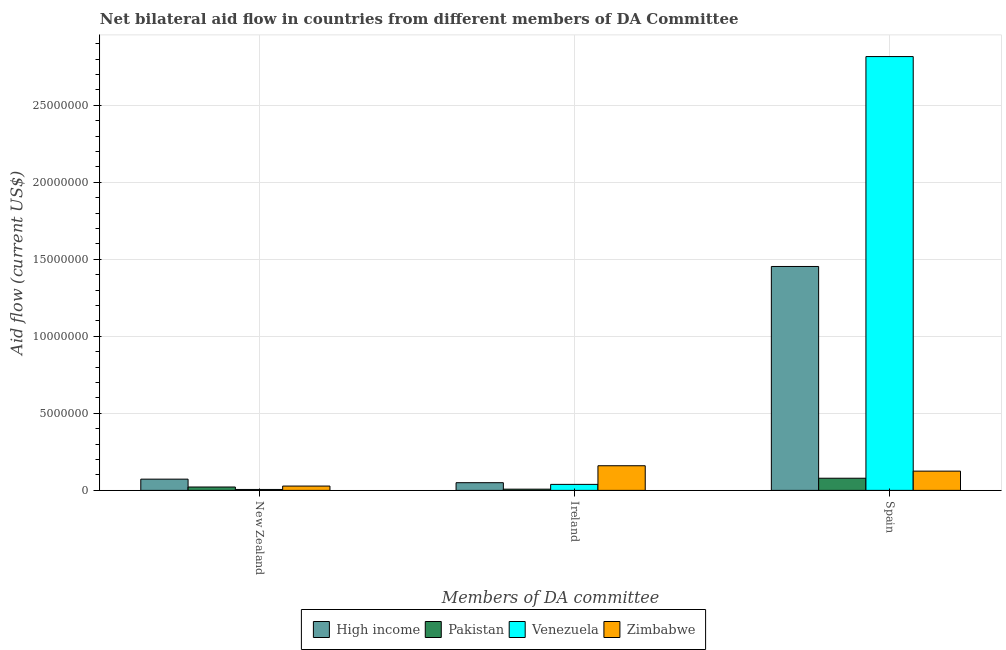How many groups of bars are there?
Provide a succinct answer. 3. Are the number of bars on each tick of the X-axis equal?
Give a very brief answer. Yes. How many bars are there on the 2nd tick from the right?
Keep it short and to the point. 4. What is the label of the 3rd group of bars from the left?
Keep it short and to the point. Spain. What is the amount of aid provided by ireland in Venezuela?
Offer a very short reply. 3.90e+05. Across all countries, what is the maximum amount of aid provided by new zealand?
Offer a very short reply. 7.30e+05. Across all countries, what is the minimum amount of aid provided by ireland?
Offer a terse response. 8.00e+04. In which country was the amount of aid provided by spain maximum?
Offer a very short reply. Venezuela. In which country was the amount of aid provided by spain minimum?
Keep it short and to the point. Pakistan. What is the total amount of aid provided by ireland in the graph?
Offer a terse response. 2.57e+06. What is the difference between the amount of aid provided by spain in High income and that in Zimbabwe?
Make the answer very short. 1.33e+07. What is the difference between the amount of aid provided by ireland in High income and the amount of aid provided by new zealand in Zimbabwe?
Offer a terse response. 2.20e+05. What is the average amount of aid provided by spain per country?
Your answer should be compact. 1.12e+07. What is the difference between the amount of aid provided by ireland and amount of aid provided by spain in High income?
Make the answer very short. -1.40e+07. In how many countries, is the amount of aid provided by ireland greater than 4000000 US$?
Ensure brevity in your answer.  0. What is the ratio of the amount of aid provided by ireland in High income to that in Zimbabwe?
Provide a succinct answer. 0.31. Is the amount of aid provided by new zealand in Pakistan less than that in Zimbabwe?
Give a very brief answer. Yes. Is the difference between the amount of aid provided by new zealand in Venezuela and Zimbabwe greater than the difference between the amount of aid provided by ireland in Venezuela and Zimbabwe?
Offer a terse response. Yes. What is the difference between the highest and the second highest amount of aid provided by ireland?
Provide a succinct answer. 1.10e+06. What is the difference between the highest and the lowest amount of aid provided by ireland?
Ensure brevity in your answer.  1.52e+06. In how many countries, is the amount of aid provided by spain greater than the average amount of aid provided by spain taken over all countries?
Keep it short and to the point. 2. What does the 3rd bar from the left in New Zealand represents?
Keep it short and to the point. Venezuela. What does the 3rd bar from the right in New Zealand represents?
Give a very brief answer. Pakistan. Are all the bars in the graph horizontal?
Your response must be concise. No. Are the values on the major ticks of Y-axis written in scientific E-notation?
Provide a succinct answer. No. Does the graph contain any zero values?
Your answer should be compact. No. Does the graph contain grids?
Provide a succinct answer. Yes. Where does the legend appear in the graph?
Make the answer very short. Bottom center. What is the title of the graph?
Give a very brief answer. Net bilateral aid flow in countries from different members of DA Committee. Does "Hong Kong" appear as one of the legend labels in the graph?
Make the answer very short. No. What is the label or title of the X-axis?
Your response must be concise. Members of DA committee. What is the Aid flow (current US$) in High income in New Zealand?
Make the answer very short. 7.30e+05. What is the Aid flow (current US$) of Pakistan in New Zealand?
Offer a terse response. 2.20e+05. What is the Aid flow (current US$) of High income in Ireland?
Make the answer very short. 5.00e+05. What is the Aid flow (current US$) of Venezuela in Ireland?
Your answer should be very brief. 3.90e+05. What is the Aid flow (current US$) in Zimbabwe in Ireland?
Offer a very short reply. 1.60e+06. What is the Aid flow (current US$) of High income in Spain?
Your answer should be compact. 1.45e+07. What is the Aid flow (current US$) of Pakistan in Spain?
Your answer should be very brief. 7.90e+05. What is the Aid flow (current US$) in Venezuela in Spain?
Make the answer very short. 2.82e+07. What is the Aid flow (current US$) in Zimbabwe in Spain?
Your answer should be compact. 1.25e+06. Across all Members of DA committee, what is the maximum Aid flow (current US$) in High income?
Make the answer very short. 1.45e+07. Across all Members of DA committee, what is the maximum Aid flow (current US$) in Pakistan?
Give a very brief answer. 7.90e+05. Across all Members of DA committee, what is the maximum Aid flow (current US$) of Venezuela?
Offer a terse response. 2.82e+07. Across all Members of DA committee, what is the maximum Aid flow (current US$) in Zimbabwe?
Your answer should be very brief. 1.60e+06. Across all Members of DA committee, what is the minimum Aid flow (current US$) of Zimbabwe?
Offer a terse response. 2.80e+05. What is the total Aid flow (current US$) in High income in the graph?
Make the answer very short. 1.58e+07. What is the total Aid flow (current US$) of Pakistan in the graph?
Make the answer very short. 1.09e+06. What is the total Aid flow (current US$) of Venezuela in the graph?
Your answer should be very brief. 2.86e+07. What is the total Aid flow (current US$) in Zimbabwe in the graph?
Provide a succinct answer. 3.13e+06. What is the difference between the Aid flow (current US$) in Venezuela in New Zealand and that in Ireland?
Give a very brief answer. -3.30e+05. What is the difference between the Aid flow (current US$) in Zimbabwe in New Zealand and that in Ireland?
Ensure brevity in your answer.  -1.32e+06. What is the difference between the Aid flow (current US$) of High income in New Zealand and that in Spain?
Give a very brief answer. -1.38e+07. What is the difference between the Aid flow (current US$) in Pakistan in New Zealand and that in Spain?
Offer a very short reply. -5.70e+05. What is the difference between the Aid flow (current US$) of Venezuela in New Zealand and that in Spain?
Your response must be concise. -2.81e+07. What is the difference between the Aid flow (current US$) in Zimbabwe in New Zealand and that in Spain?
Give a very brief answer. -9.70e+05. What is the difference between the Aid flow (current US$) in High income in Ireland and that in Spain?
Offer a very short reply. -1.40e+07. What is the difference between the Aid flow (current US$) of Pakistan in Ireland and that in Spain?
Your response must be concise. -7.10e+05. What is the difference between the Aid flow (current US$) of Venezuela in Ireland and that in Spain?
Your response must be concise. -2.78e+07. What is the difference between the Aid flow (current US$) in Zimbabwe in Ireland and that in Spain?
Provide a short and direct response. 3.50e+05. What is the difference between the Aid flow (current US$) of High income in New Zealand and the Aid flow (current US$) of Pakistan in Ireland?
Your answer should be compact. 6.50e+05. What is the difference between the Aid flow (current US$) of High income in New Zealand and the Aid flow (current US$) of Zimbabwe in Ireland?
Provide a succinct answer. -8.70e+05. What is the difference between the Aid flow (current US$) of Pakistan in New Zealand and the Aid flow (current US$) of Zimbabwe in Ireland?
Offer a terse response. -1.38e+06. What is the difference between the Aid flow (current US$) in Venezuela in New Zealand and the Aid flow (current US$) in Zimbabwe in Ireland?
Provide a short and direct response. -1.54e+06. What is the difference between the Aid flow (current US$) in High income in New Zealand and the Aid flow (current US$) in Venezuela in Spain?
Offer a terse response. -2.74e+07. What is the difference between the Aid flow (current US$) of High income in New Zealand and the Aid flow (current US$) of Zimbabwe in Spain?
Keep it short and to the point. -5.20e+05. What is the difference between the Aid flow (current US$) of Pakistan in New Zealand and the Aid flow (current US$) of Venezuela in Spain?
Keep it short and to the point. -2.80e+07. What is the difference between the Aid flow (current US$) in Pakistan in New Zealand and the Aid flow (current US$) in Zimbabwe in Spain?
Your answer should be compact. -1.03e+06. What is the difference between the Aid flow (current US$) of Venezuela in New Zealand and the Aid flow (current US$) of Zimbabwe in Spain?
Offer a very short reply. -1.19e+06. What is the difference between the Aid flow (current US$) in High income in Ireland and the Aid flow (current US$) in Pakistan in Spain?
Keep it short and to the point. -2.90e+05. What is the difference between the Aid flow (current US$) in High income in Ireland and the Aid flow (current US$) in Venezuela in Spain?
Ensure brevity in your answer.  -2.77e+07. What is the difference between the Aid flow (current US$) of High income in Ireland and the Aid flow (current US$) of Zimbabwe in Spain?
Your response must be concise. -7.50e+05. What is the difference between the Aid flow (current US$) of Pakistan in Ireland and the Aid flow (current US$) of Venezuela in Spain?
Make the answer very short. -2.81e+07. What is the difference between the Aid flow (current US$) of Pakistan in Ireland and the Aid flow (current US$) of Zimbabwe in Spain?
Offer a very short reply. -1.17e+06. What is the difference between the Aid flow (current US$) of Venezuela in Ireland and the Aid flow (current US$) of Zimbabwe in Spain?
Your answer should be compact. -8.60e+05. What is the average Aid flow (current US$) of High income per Members of DA committee?
Offer a very short reply. 5.26e+06. What is the average Aid flow (current US$) of Pakistan per Members of DA committee?
Provide a short and direct response. 3.63e+05. What is the average Aid flow (current US$) of Venezuela per Members of DA committee?
Ensure brevity in your answer.  9.54e+06. What is the average Aid flow (current US$) in Zimbabwe per Members of DA committee?
Give a very brief answer. 1.04e+06. What is the difference between the Aid flow (current US$) of High income and Aid flow (current US$) of Pakistan in New Zealand?
Keep it short and to the point. 5.10e+05. What is the difference between the Aid flow (current US$) in High income and Aid flow (current US$) in Venezuela in New Zealand?
Keep it short and to the point. 6.70e+05. What is the difference between the Aid flow (current US$) of High income and Aid flow (current US$) of Zimbabwe in New Zealand?
Ensure brevity in your answer.  4.50e+05. What is the difference between the Aid flow (current US$) of Pakistan and Aid flow (current US$) of Zimbabwe in New Zealand?
Provide a short and direct response. -6.00e+04. What is the difference between the Aid flow (current US$) in High income and Aid flow (current US$) in Venezuela in Ireland?
Ensure brevity in your answer.  1.10e+05. What is the difference between the Aid flow (current US$) of High income and Aid flow (current US$) of Zimbabwe in Ireland?
Make the answer very short. -1.10e+06. What is the difference between the Aid flow (current US$) in Pakistan and Aid flow (current US$) in Venezuela in Ireland?
Provide a succinct answer. -3.10e+05. What is the difference between the Aid flow (current US$) of Pakistan and Aid flow (current US$) of Zimbabwe in Ireland?
Make the answer very short. -1.52e+06. What is the difference between the Aid flow (current US$) in Venezuela and Aid flow (current US$) in Zimbabwe in Ireland?
Your answer should be very brief. -1.21e+06. What is the difference between the Aid flow (current US$) of High income and Aid flow (current US$) of Pakistan in Spain?
Your answer should be compact. 1.38e+07. What is the difference between the Aid flow (current US$) of High income and Aid flow (current US$) of Venezuela in Spain?
Your response must be concise. -1.36e+07. What is the difference between the Aid flow (current US$) of High income and Aid flow (current US$) of Zimbabwe in Spain?
Provide a short and direct response. 1.33e+07. What is the difference between the Aid flow (current US$) in Pakistan and Aid flow (current US$) in Venezuela in Spain?
Your answer should be very brief. -2.74e+07. What is the difference between the Aid flow (current US$) in Pakistan and Aid flow (current US$) in Zimbabwe in Spain?
Offer a very short reply. -4.60e+05. What is the difference between the Aid flow (current US$) in Venezuela and Aid flow (current US$) in Zimbabwe in Spain?
Provide a short and direct response. 2.69e+07. What is the ratio of the Aid flow (current US$) in High income in New Zealand to that in Ireland?
Your answer should be compact. 1.46. What is the ratio of the Aid flow (current US$) of Pakistan in New Zealand to that in Ireland?
Your answer should be very brief. 2.75. What is the ratio of the Aid flow (current US$) of Venezuela in New Zealand to that in Ireland?
Provide a short and direct response. 0.15. What is the ratio of the Aid flow (current US$) of Zimbabwe in New Zealand to that in Ireland?
Provide a short and direct response. 0.17. What is the ratio of the Aid flow (current US$) of High income in New Zealand to that in Spain?
Ensure brevity in your answer.  0.05. What is the ratio of the Aid flow (current US$) in Pakistan in New Zealand to that in Spain?
Keep it short and to the point. 0.28. What is the ratio of the Aid flow (current US$) in Venezuela in New Zealand to that in Spain?
Make the answer very short. 0. What is the ratio of the Aid flow (current US$) of Zimbabwe in New Zealand to that in Spain?
Give a very brief answer. 0.22. What is the ratio of the Aid flow (current US$) of High income in Ireland to that in Spain?
Your answer should be compact. 0.03. What is the ratio of the Aid flow (current US$) of Pakistan in Ireland to that in Spain?
Offer a very short reply. 0.1. What is the ratio of the Aid flow (current US$) of Venezuela in Ireland to that in Spain?
Provide a succinct answer. 0.01. What is the ratio of the Aid flow (current US$) of Zimbabwe in Ireland to that in Spain?
Ensure brevity in your answer.  1.28. What is the difference between the highest and the second highest Aid flow (current US$) of High income?
Provide a short and direct response. 1.38e+07. What is the difference between the highest and the second highest Aid flow (current US$) of Pakistan?
Your answer should be very brief. 5.70e+05. What is the difference between the highest and the second highest Aid flow (current US$) of Venezuela?
Make the answer very short. 2.78e+07. What is the difference between the highest and the second highest Aid flow (current US$) in Zimbabwe?
Your answer should be very brief. 3.50e+05. What is the difference between the highest and the lowest Aid flow (current US$) in High income?
Make the answer very short. 1.40e+07. What is the difference between the highest and the lowest Aid flow (current US$) of Pakistan?
Provide a short and direct response. 7.10e+05. What is the difference between the highest and the lowest Aid flow (current US$) of Venezuela?
Your response must be concise. 2.81e+07. What is the difference between the highest and the lowest Aid flow (current US$) of Zimbabwe?
Make the answer very short. 1.32e+06. 